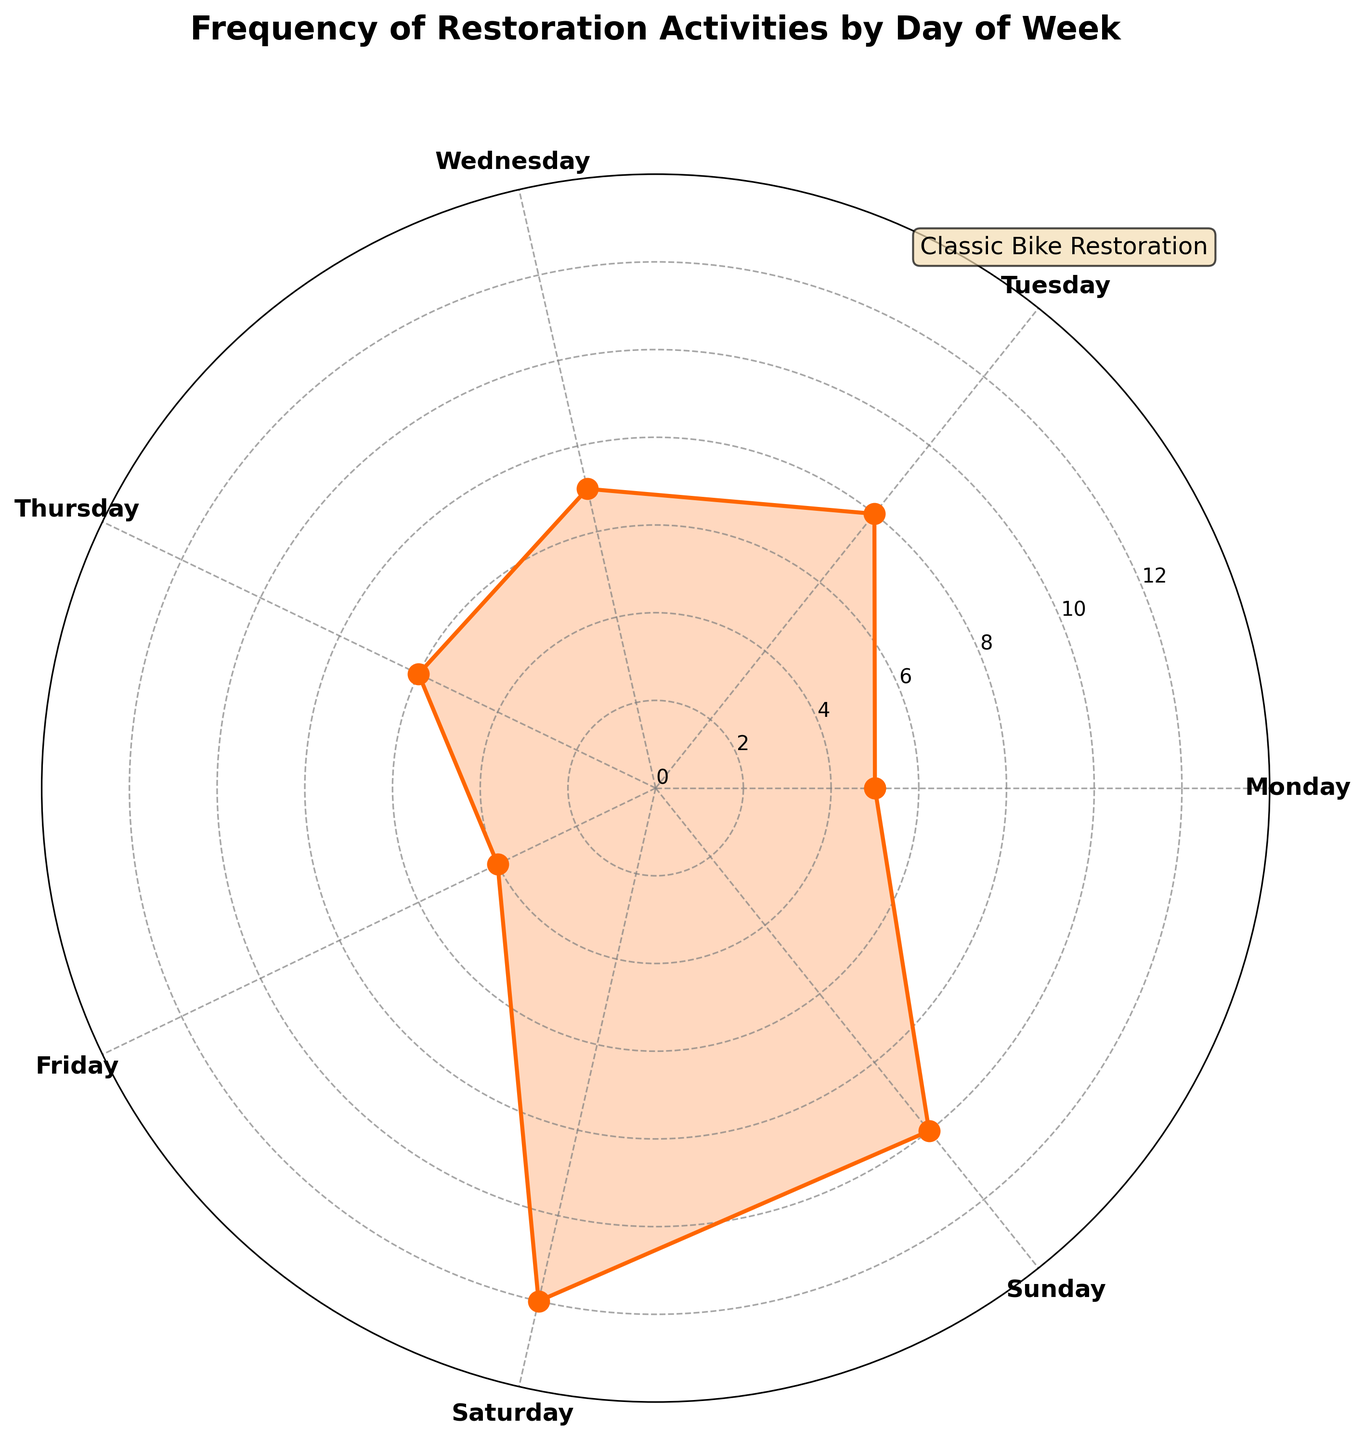What's the title of the figure? The title is usually located at the top of the figure and summarizes its content. In this case, it reads "Frequency of Restoration Activities by Day of Week".
Answer: Frequency of Restoration Activities by Day of Week Which day has the highest frequency of restoration activities? By examining the plot, we see the peak of the chart. The highest point corresponds to Saturday.
Answer: Saturday How many data points are plotted? The chart displays the frequencies for each day of the week. There are 7 days, and thus, 7 data points are plotted.
Answer: 7 What is the frequency of restoration activities on Sunday? By checking the y-axis value corresponding to Sunday on the plot, we find the frequency is 10.
Answer: 10 Which days have a frequency of restoration activities greater than 5? By observing the chart, we identify days with frequencies above the level '5' on the y-axis: Tuesday, Wednesday, Thursday, Saturday, and Sunday.
Answer: Tuesday, Wednesday, Thursday, Saturday, Sunday What's the difference in frequency of restoration activities between Saturday and Monday? The frequency on Saturday is 12 and on Monday is 5. The difference is calculated as 12 - 5.
Answer: 7 What’s the average frequency of restoration activities from Monday to Friday? The frequencies for Monday to Friday are 5, 8, 7, 6, and 4. The average is calculated as (5+8+7+6+4)/5.
Answer: 6 Which day has the lowest activity frequency and what is that frequency? By looking at the plot, we identify the lowest point on the chart. The lowest frequency is on Friday, which is 4.
Answer: Friday, 4 Do the frequencies form a closed loop on the Polar Chart? In general, Polar Charts can be designed to form a closed loop. In this chart, the data points have been connected end-to-end and wrapped around back to the beginning to show cyclical data.
Answer: Yes 